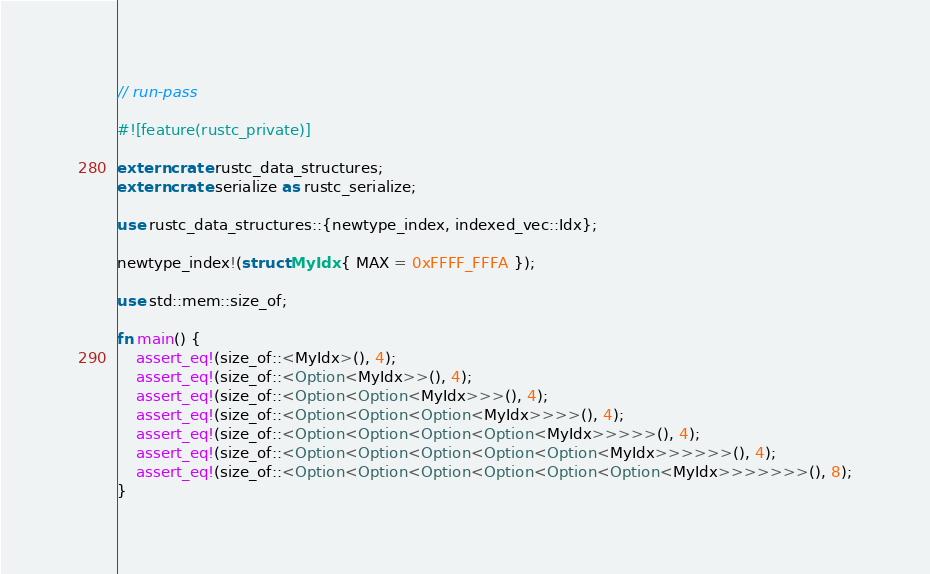<code> <loc_0><loc_0><loc_500><loc_500><_Rust_>// run-pass

#![feature(rustc_private)]

extern crate rustc_data_structures;
extern crate serialize as rustc_serialize;

use rustc_data_structures::{newtype_index, indexed_vec::Idx};

newtype_index!(struct MyIdx { MAX = 0xFFFF_FFFA });

use std::mem::size_of;

fn main() {
    assert_eq!(size_of::<MyIdx>(), 4);
    assert_eq!(size_of::<Option<MyIdx>>(), 4);
    assert_eq!(size_of::<Option<Option<MyIdx>>>(), 4);
    assert_eq!(size_of::<Option<Option<Option<MyIdx>>>>(), 4);
    assert_eq!(size_of::<Option<Option<Option<Option<MyIdx>>>>>(), 4);
    assert_eq!(size_of::<Option<Option<Option<Option<Option<MyIdx>>>>>>(), 4);
    assert_eq!(size_of::<Option<Option<Option<Option<Option<Option<MyIdx>>>>>>>(), 8);
}
</code> 